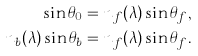Convert formula to latex. <formula><loc_0><loc_0><loc_500><loc_500>\sin \theta _ { 0 } = n _ { f } ( \lambda ) \sin \theta _ { f } , \\ n _ { b } ( \lambda ) \sin \theta _ { b } = n _ { f } ( \lambda ) \sin \theta _ { f } .</formula> 